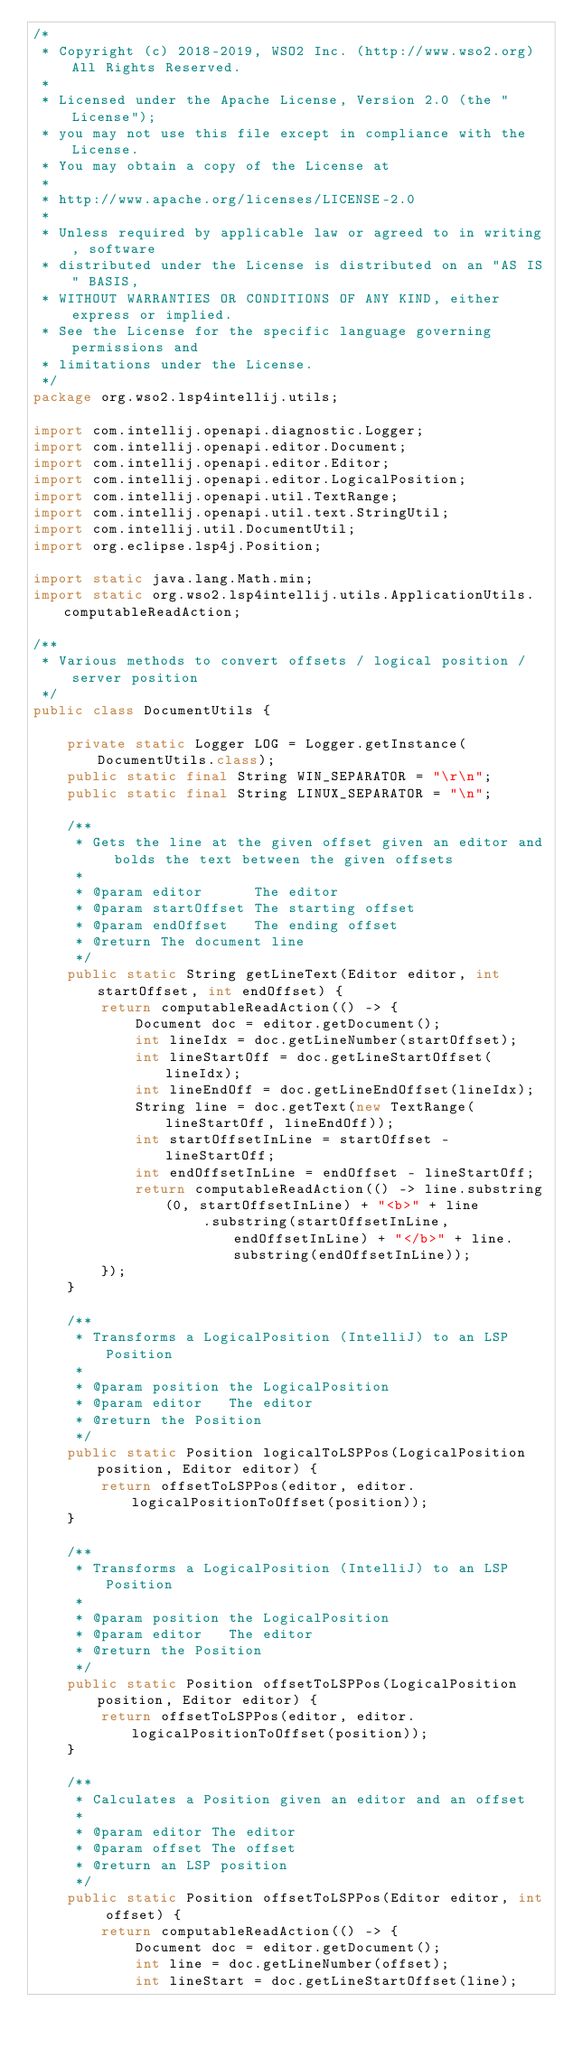<code> <loc_0><loc_0><loc_500><loc_500><_Java_>/*
 * Copyright (c) 2018-2019, WSO2 Inc. (http://www.wso2.org) All Rights Reserved.
 *
 * Licensed under the Apache License, Version 2.0 (the "License");
 * you may not use this file except in compliance with the License.
 * You may obtain a copy of the License at
 *
 * http://www.apache.org/licenses/LICENSE-2.0
 *
 * Unless required by applicable law or agreed to in writing, software
 * distributed under the License is distributed on an "AS IS" BASIS,
 * WITHOUT WARRANTIES OR CONDITIONS OF ANY KIND, either express or implied.
 * See the License for the specific language governing permissions and
 * limitations under the License.
 */
package org.wso2.lsp4intellij.utils;

import com.intellij.openapi.diagnostic.Logger;
import com.intellij.openapi.editor.Document;
import com.intellij.openapi.editor.Editor;
import com.intellij.openapi.editor.LogicalPosition;
import com.intellij.openapi.util.TextRange;
import com.intellij.openapi.util.text.StringUtil;
import com.intellij.util.DocumentUtil;
import org.eclipse.lsp4j.Position;

import static java.lang.Math.min;
import static org.wso2.lsp4intellij.utils.ApplicationUtils.computableReadAction;

/**
 * Various methods to convert offsets / logical position / server position
 */
public class DocumentUtils {

    private static Logger LOG = Logger.getInstance(DocumentUtils.class);
    public static final String WIN_SEPARATOR = "\r\n";
    public static final String LINUX_SEPARATOR = "\n";

    /**
     * Gets the line at the given offset given an editor and bolds the text between the given offsets
     *
     * @param editor      The editor
     * @param startOffset The starting offset
     * @param endOffset   The ending offset
     * @return The document line
     */
    public static String getLineText(Editor editor, int startOffset, int endOffset) {
        return computableReadAction(() -> {
            Document doc = editor.getDocument();
            int lineIdx = doc.getLineNumber(startOffset);
            int lineStartOff = doc.getLineStartOffset(lineIdx);
            int lineEndOff = doc.getLineEndOffset(lineIdx);
            String line = doc.getText(new TextRange(lineStartOff, lineEndOff));
            int startOffsetInLine = startOffset - lineStartOff;
            int endOffsetInLine = endOffset - lineStartOff;
            return computableReadAction(() -> line.substring(0, startOffsetInLine) + "<b>" + line
                    .substring(startOffsetInLine, endOffsetInLine) + "</b>" + line.substring(endOffsetInLine));
        });
    }

    /**
     * Transforms a LogicalPosition (IntelliJ) to an LSP Position
     *
     * @param position the LogicalPosition
     * @param editor   The editor
     * @return the Position
     */
    public static Position logicalToLSPPos(LogicalPosition position, Editor editor) {
        return offsetToLSPPos(editor, editor.logicalPositionToOffset(position));
    }

    /**
     * Transforms a LogicalPosition (IntelliJ) to an LSP Position
     *
     * @param position the LogicalPosition
     * @param editor   The editor
     * @return the Position
     */
    public static Position offsetToLSPPos(LogicalPosition position, Editor editor) {
        return offsetToLSPPos(editor, editor.logicalPositionToOffset(position));
    }

    /**
     * Calculates a Position given an editor and an offset
     *
     * @param editor The editor
     * @param offset The offset
     * @return an LSP position
     */
    public static Position offsetToLSPPos(Editor editor, int offset) {
        return computableReadAction(() -> {
            Document doc = editor.getDocument();
            int line = doc.getLineNumber(offset);
            int lineStart = doc.getLineStartOffset(line);</code> 